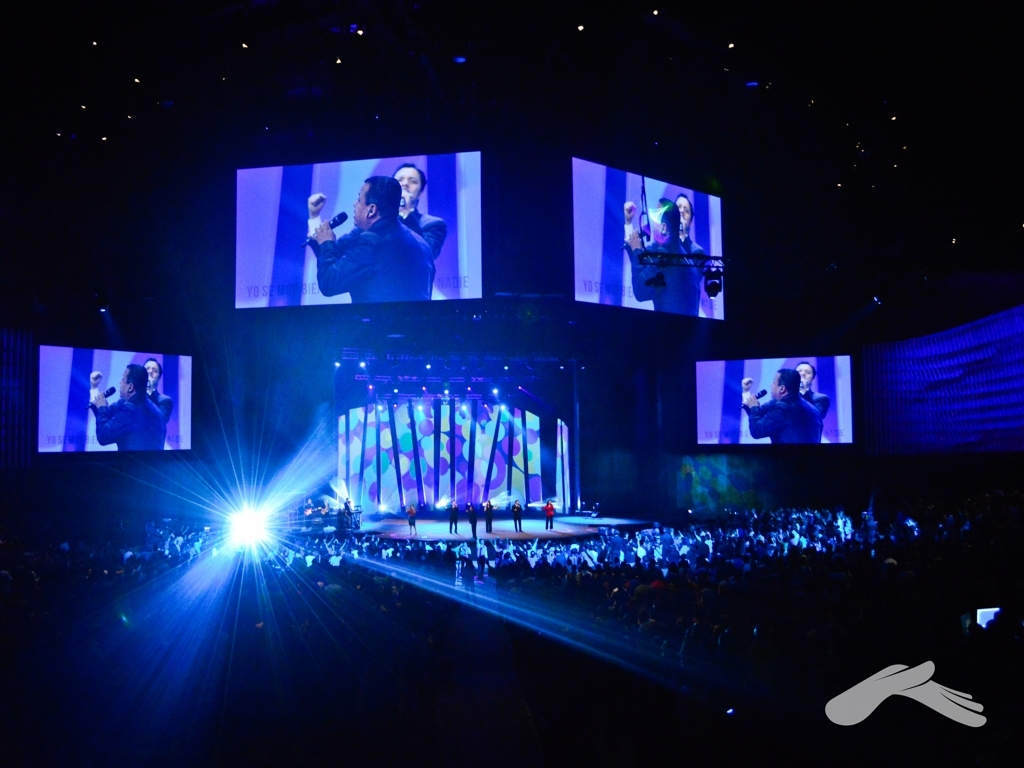Can you describe what's happening in this scene? The image captures a moment during a live performance, likely a concert or event, where the spotlight is on a figure on stage who is addressing the audience. Large screens display the speaker, ensuring that the entire audience can see the performance, despite the size of the venue. What kind of emotions does this image evoke? The intense lighting and focused attention on the central figure suggest a charged atmosphere, likely filled with anticipation or excitement. The scale of the event and the collective attention of the audience may evoke feelings of shared experience and community. 